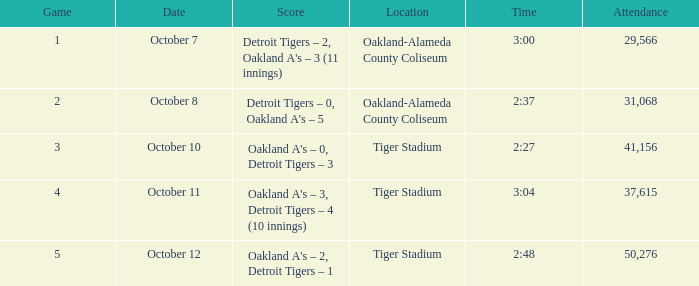During game 2, how many individuals are attending the event at oakland-alameda county coliseum? 31068.0. 